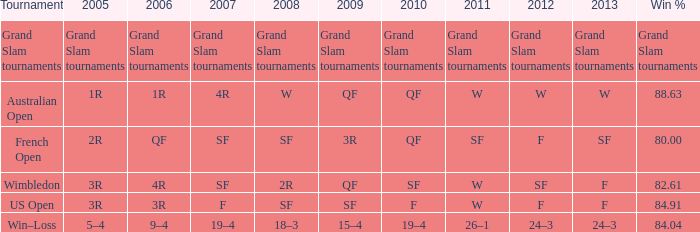When in 2008 that has a 2007 of f? SF. 